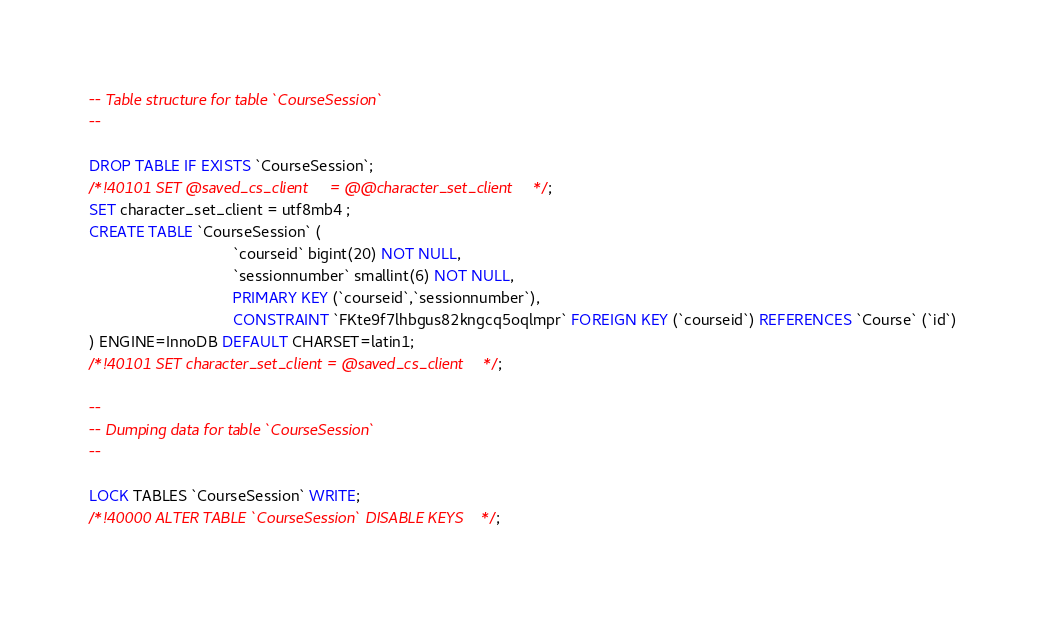Convert code to text. <code><loc_0><loc_0><loc_500><loc_500><_SQL_>-- Table structure for table `CourseSession`
--

DROP TABLE IF EXISTS `CourseSession`;
/*!40101 SET @saved_cs_client     = @@character_set_client */;
SET character_set_client = utf8mb4 ;
CREATE TABLE `CourseSession` (
                                 `courseid` bigint(20) NOT NULL,
                                 `sessionnumber` smallint(6) NOT NULL,
                                 PRIMARY KEY (`courseid`,`sessionnumber`),
                                 CONSTRAINT `FKte9f7lhbgus82kngcq5oqlmpr` FOREIGN KEY (`courseid`) REFERENCES `Course` (`id`)
) ENGINE=InnoDB DEFAULT CHARSET=latin1;
/*!40101 SET character_set_client = @saved_cs_client */;

--
-- Dumping data for table `CourseSession`
--

LOCK TABLES `CourseSession` WRITE;
/*!40000 ALTER TABLE `CourseSession` DISABLE KEYS */;</code> 